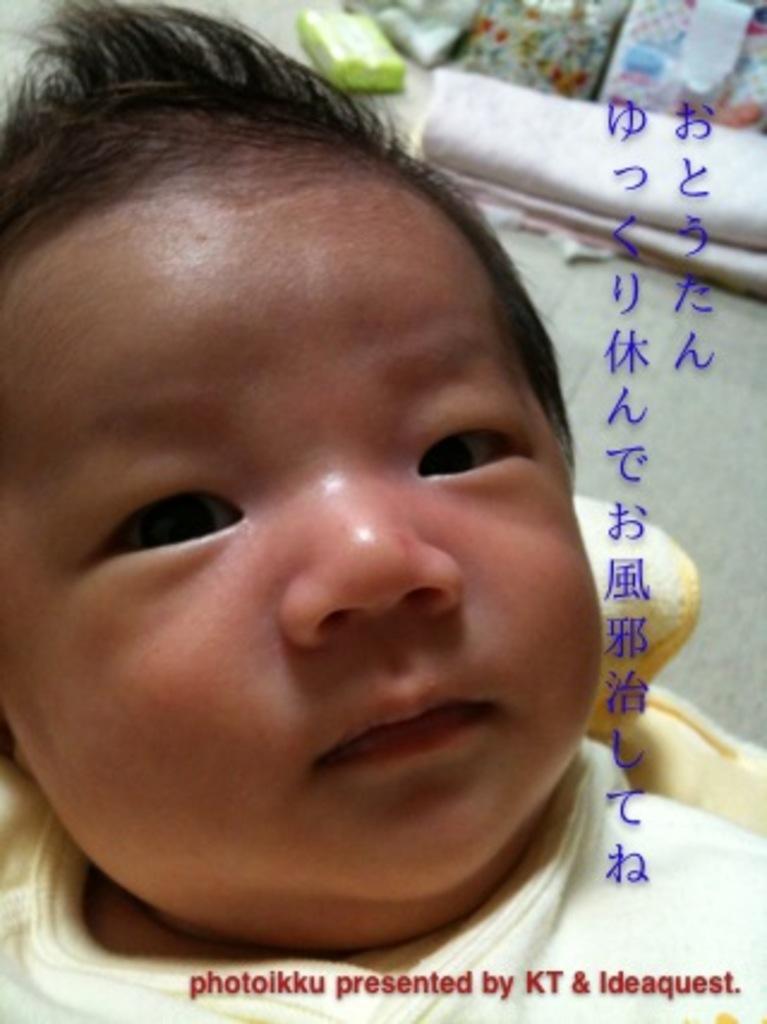How would you summarize this image in a sentence or two? In this image I can see a baby, text and some objects in the background. This image is taken, may be in a room. 